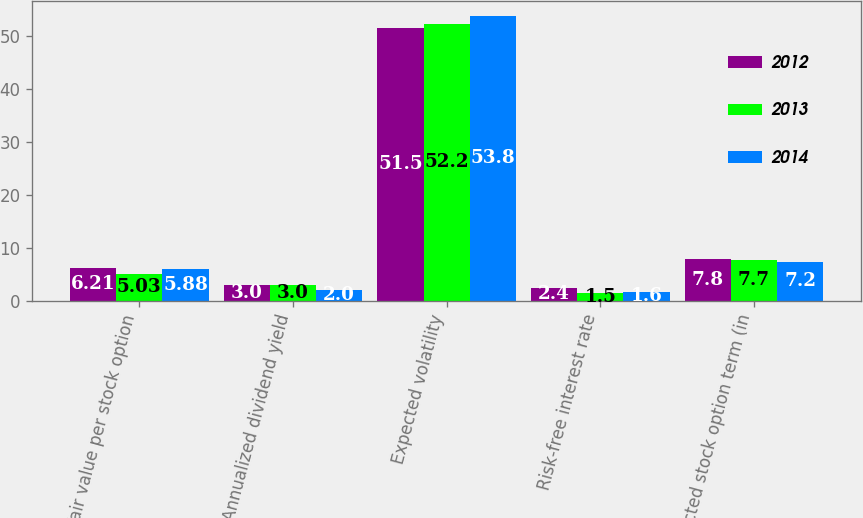<chart> <loc_0><loc_0><loc_500><loc_500><stacked_bar_chart><ecel><fcel>Fair value per stock option<fcel>Annualized dividend yield<fcel>Expected volatility<fcel>Risk-free interest rate<fcel>Expected stock option term (in<nl><fcel>2012<fcel>6.21<fcel>3<fcel>51.5<fcel>2.4<fcel>7.8<nl><fcel>2013<fcel>5.03<fcel>3<fcel>52.2<fcel>1.5<fcel>7.7<nl><fcel>2014<fcel>5.88<fcel>2<fcel>53.8<fcel>1.6<fcel>7.2<nl></chart> 